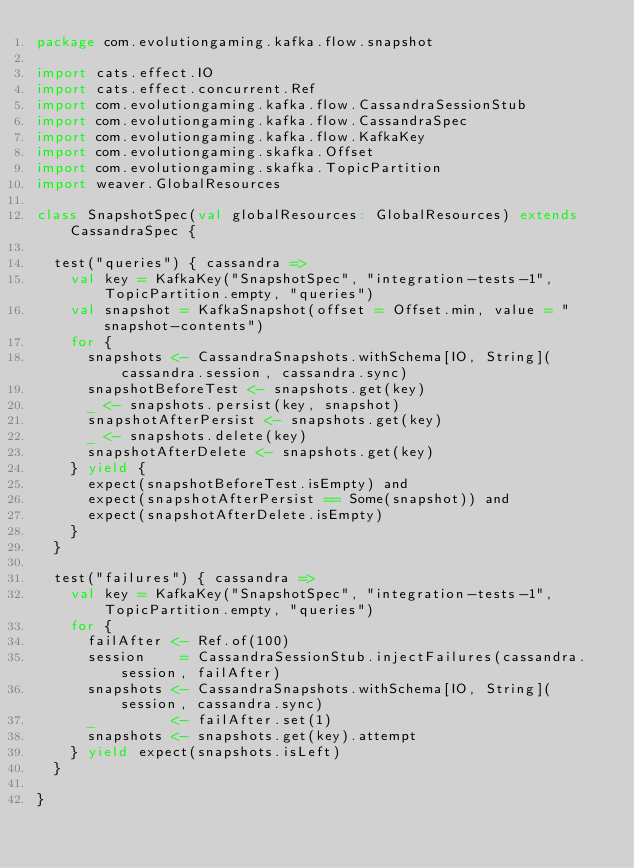Convert code to text. <code><loc_0><loc_0><loc_500><loc_500><_Scala_>package com.evolutiongaming.kafka.flow.snapshot

import cats.effect.IO
import cats.effect.concurrent.Ref
import com.evolutiongaming.kafka.flow.CassandraSessionStub
import com.evolutiongaming.kafka.flow.CassandraSpec
import com.evolutiongaming.kafka.flow.KafkaKey
import com.evolutiongaming.skafka.Offset
import com.evolutiongaming.skafka.TopicPartition
import weaver.GlobalResources

class SnapshotSpec(val globalResources: GlobalResources) extends CassandraSpec {

  test("queries") { cassandra =>
    val key = KafkaKey("SnapshotSpec", "integration-tests-1", TopicPartition.empty, "queries")
    val snapshot = KafkaSnapshot(offset = Offset.min, value = "snapshot-contents")
    for {
      snapshots <- CassandraSnapshots.withSchema[IO, String](cassandra.session, cassandra.sync)
      snapshotBeforeTest <- snapshots.get(key)
      _ <- snapshots.persist(key, snapshot)
      snapshotAfterPersist <- snapshots.get(key)
      _ <- snapshots.delete(key)
      snapshotAfterDelete <- snapshots.get(key)
    } yield {
      expect(snapshotBeforeTest.isEmpty) and
      expect(snapshotAfterPersist == Some(snapshot)) and
      expect(snapshotAfterDelete.isEmpty)
    }
  }

  test("failures") { cassandra =>
    val key = KafkaKey("SnapshotSpec", "integration-tests-1", TopicPartition.empty, "queries")
    for {
      failAfter <- Ref.of(100)
      session    = CassandraSessionStub.injectFailures(cassandra.session, failAfter)
      snapshots <- CassandraSnapshots.withSchema[IO, String](session, cassandra.sync)
      _         <- failAfter.set(1)
      snapshots <- snapshots.get(key).attempt
    } yield expect(snapshots.isLeft)
  }

}
</code> 